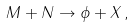<formula> <loc_0><loc_0><loc_500><loc_500>M + N \rightarrow \phi + X \, ,</formula> 